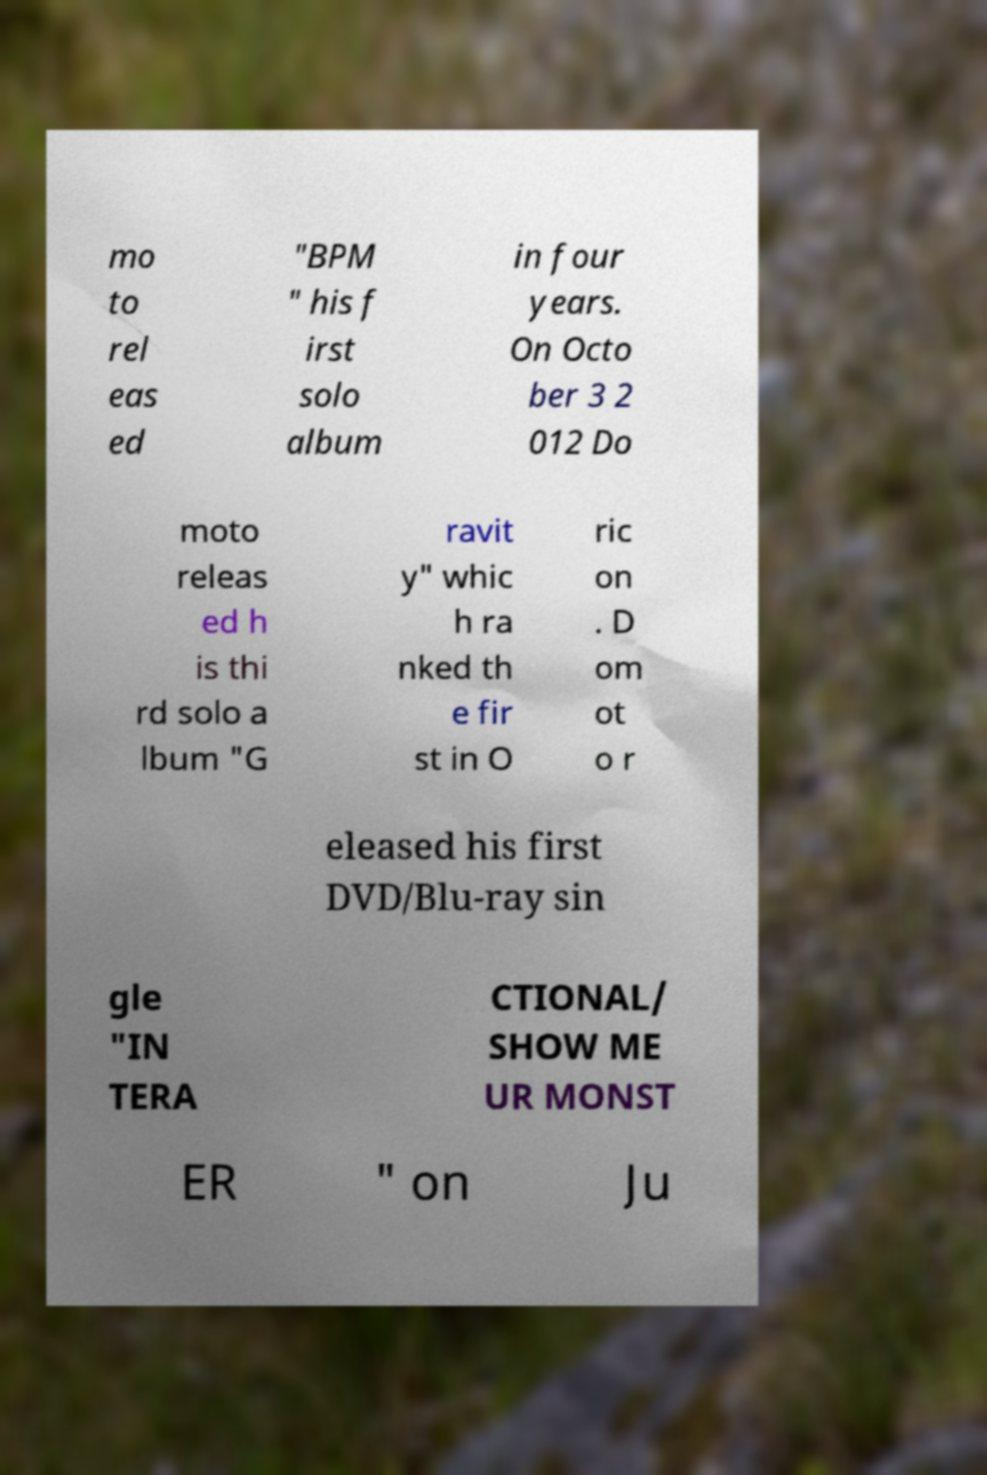Please identify and transcribe the text found in this image. mo to rel eas ed "BPM " his f irst solo album in four years. On Octo ber 3 2 012 Do moto releas ed h is thi rd solo a lbum "G ravit y" whic h ra nked th e fir st in O ric on . D om ot o r eleased his first DVD/Blu-ray sin gle "IN TERA CTIONAL/ SHOW ME UR MONST ER " on Ju 